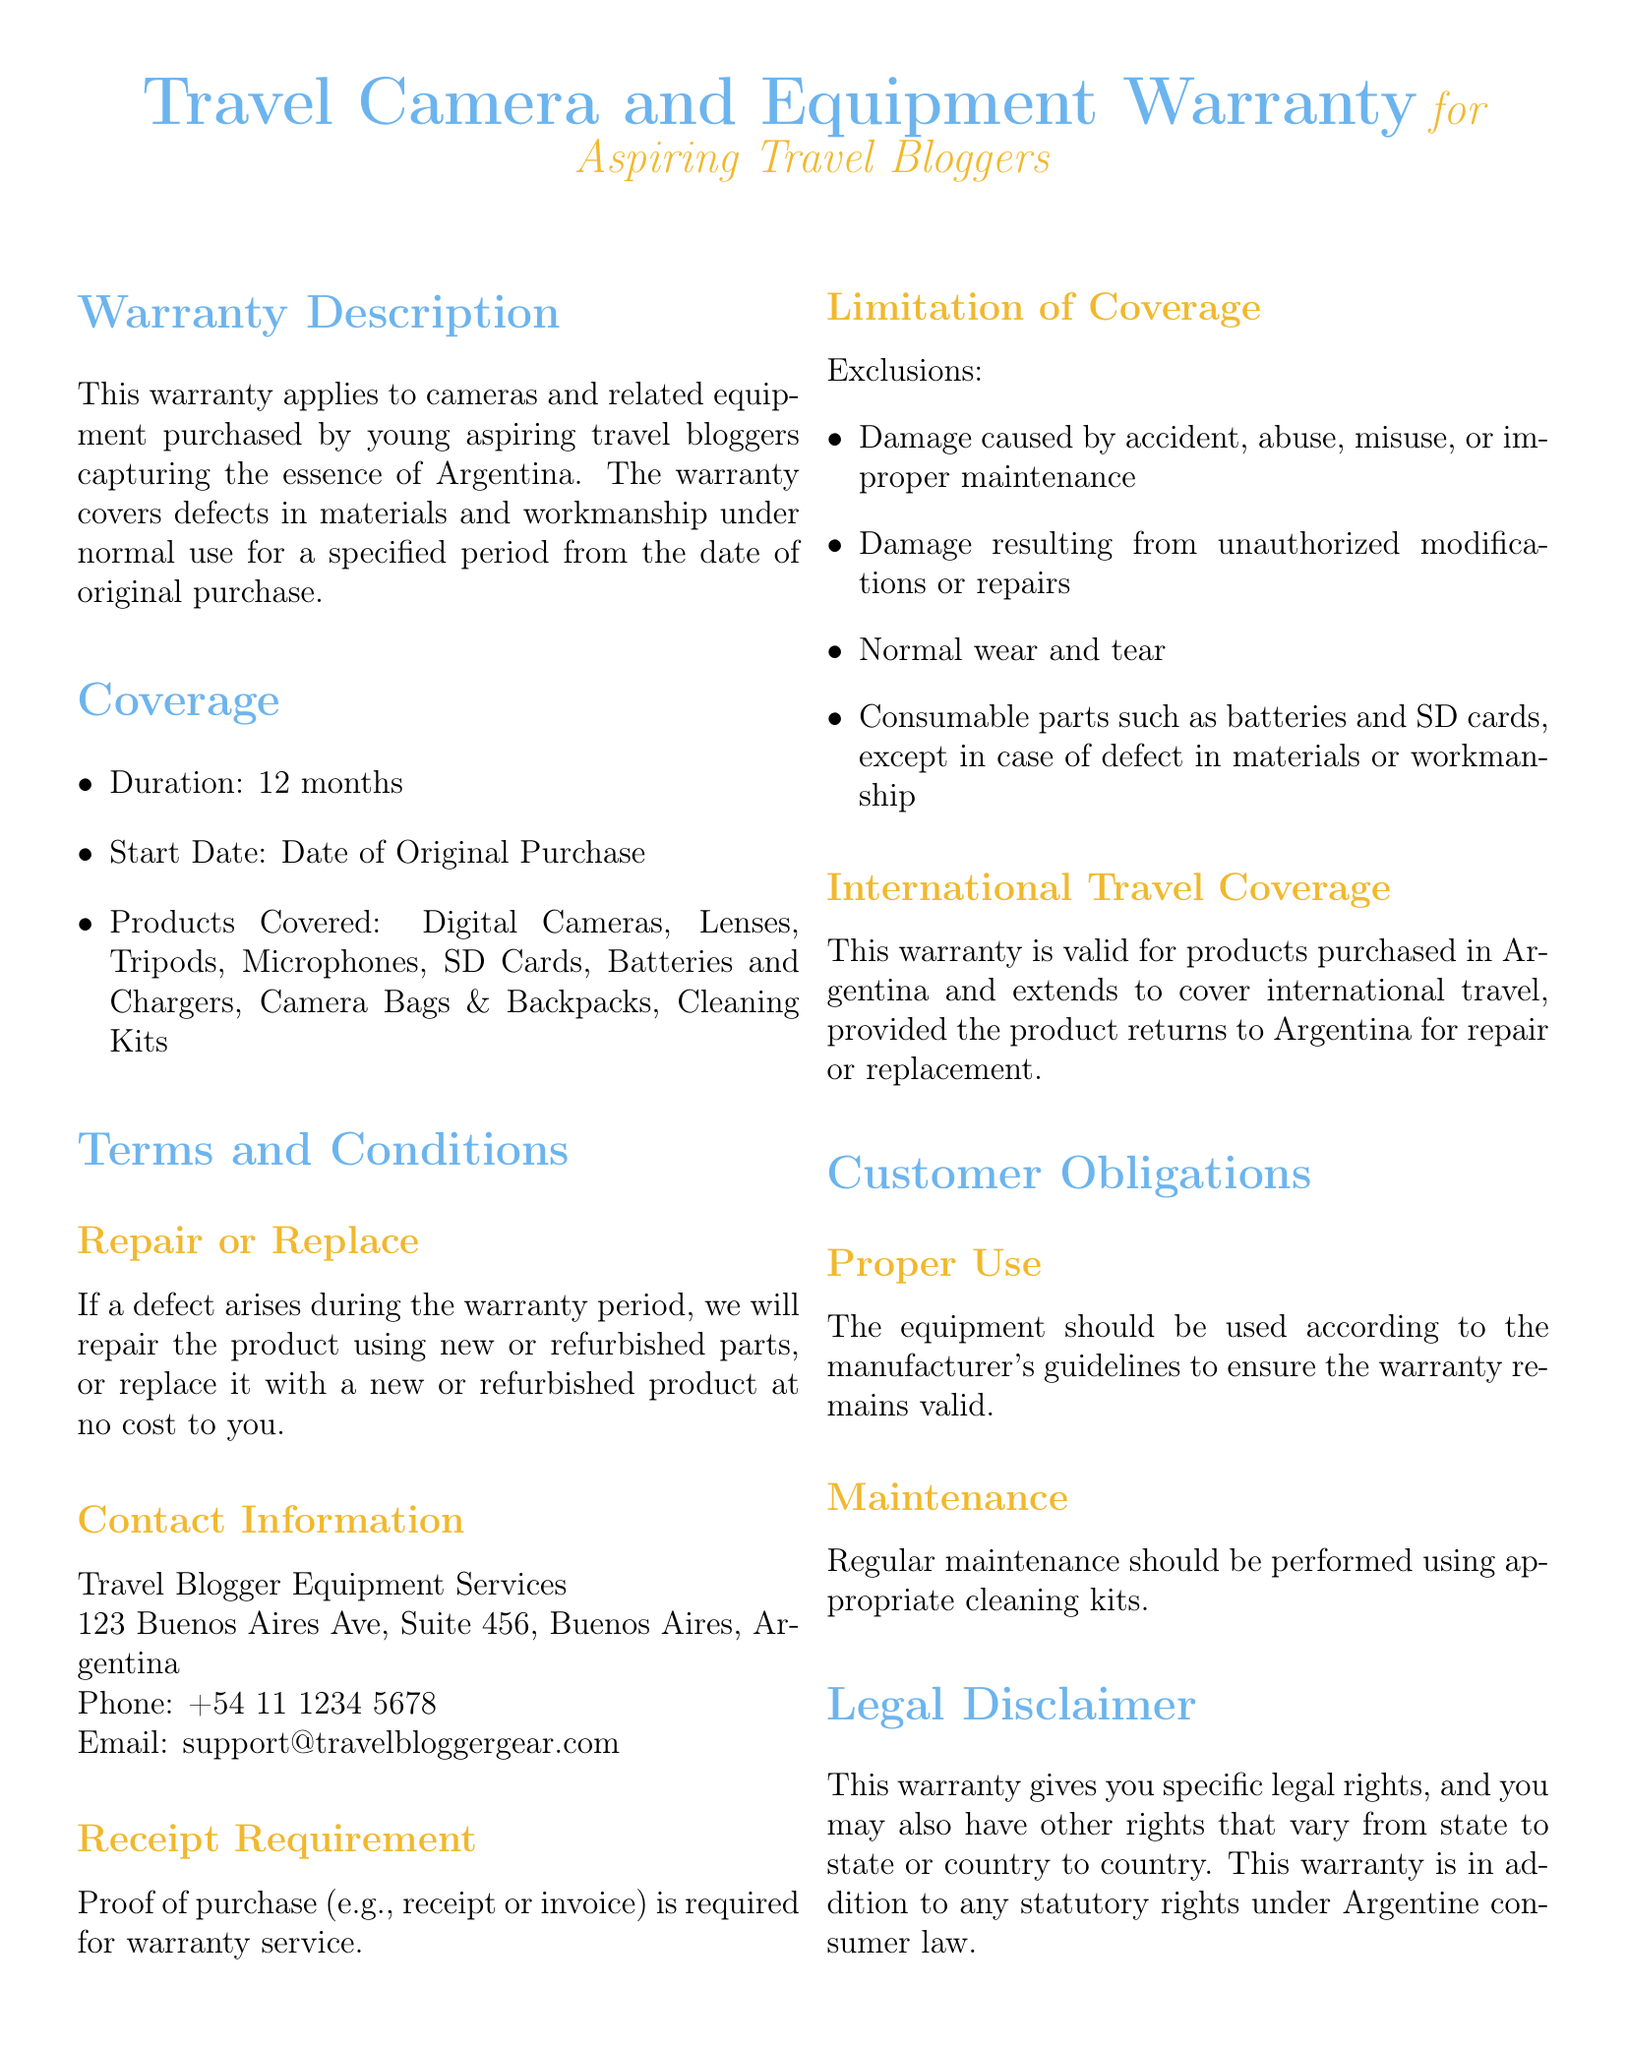What is the duration of the warranty? The duration of the warranty is specified as 12 months in the document.
Answer: 12 months What is required for warranty service? The document states that proof of purchase (e.g., receipt or invoice) is required for warranty service.
Answer: Proof of purchase Who can be contacted for support? The document provides a contact name and address for support, stating "Travel Blogger Equipment Services" along with an address and phone number.
Answer: Travel Blogger Equipment Services What types of products are covered under this warranty? The warranty covers several products including digital cameras, lenses, tripods, microphones, and others as listed.
Answer: Digital Cameras, Lenses, Tripods, Microphones, SD Cards, Batteries and Chargers, Camera Bags & Backpacks, Cleaning Kits What is excluded from the warranty coverage? The document lists several exclusions including damage caused by accident, misuse, and normal wear and tear.
Answer: Damage caused by accident, misuse, or improper maintenance Where is the warranty valid? According to the document, the warranty is valid for products purchased in Argentina and extends to cover international travel.
Answer: Products purchased in Argentina What should be performed regularly to maintain warranty validity? The document highlights that regular maintenance should be performed using appropriate cleaning kits.
Answer: Regular maintenance What happens if a defect arises during the warranty period? The document mentions that if a defect arises, they will repair or replace the product at no cost.
Answer: Repair or replace the product What should you do if the equipment is misused? The document states that damage caused by misuse is an exclusion under the warranty.
Answer: Damage exclusion 